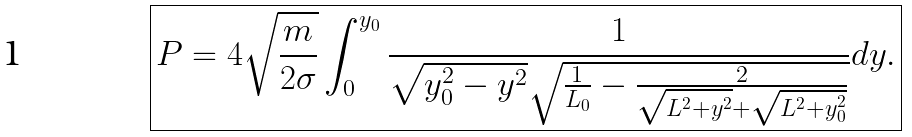<formula> <loc_0><loc_0><loc_500><loc_500>\boxed { P = 4 \sqrt { \frac { m } { 2 \sigma } } \int _ { 0 } ^ { y _ { 0 } } \frac { 1 } { \sqrt { y _ { 0 } ^ { 2 } - y ^ { 2 } } \sqrt { \frac { 1 } { L _ { 0 } } - \frac { 2 } { \sqrt { L ^ { 2 } + y ^ { 2 } } + \sqrt { L ^ { 2 } + y _ { 0 } ^ { 2 } } } } } d y . }</formula> 